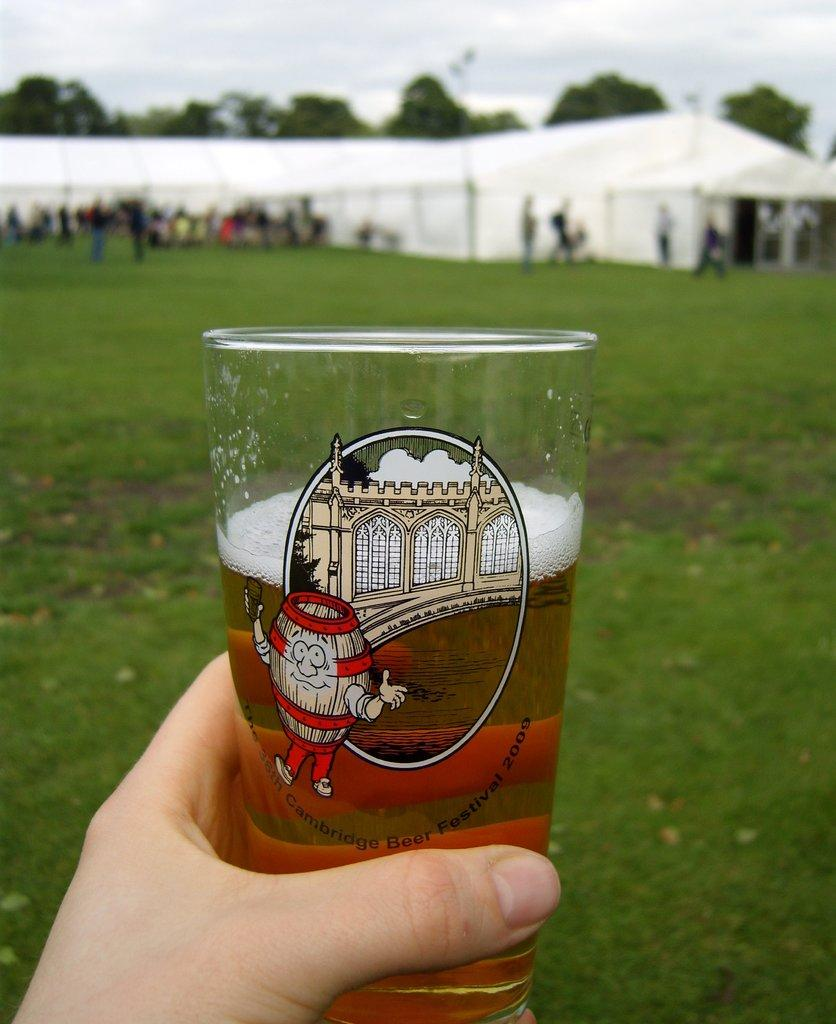What is in the foreground of the image? There is a hand with a glass of drink in the foreground of the image. What can be seen in the background of the image? There are tents, trees, and people in the background of the image. What is the condition of the sky in the image? The sky is cloudy in the image. How many hands are visible on the calendar in the image? There is no calendar present in the image, and therefore no hands can be seen on a calendar. 